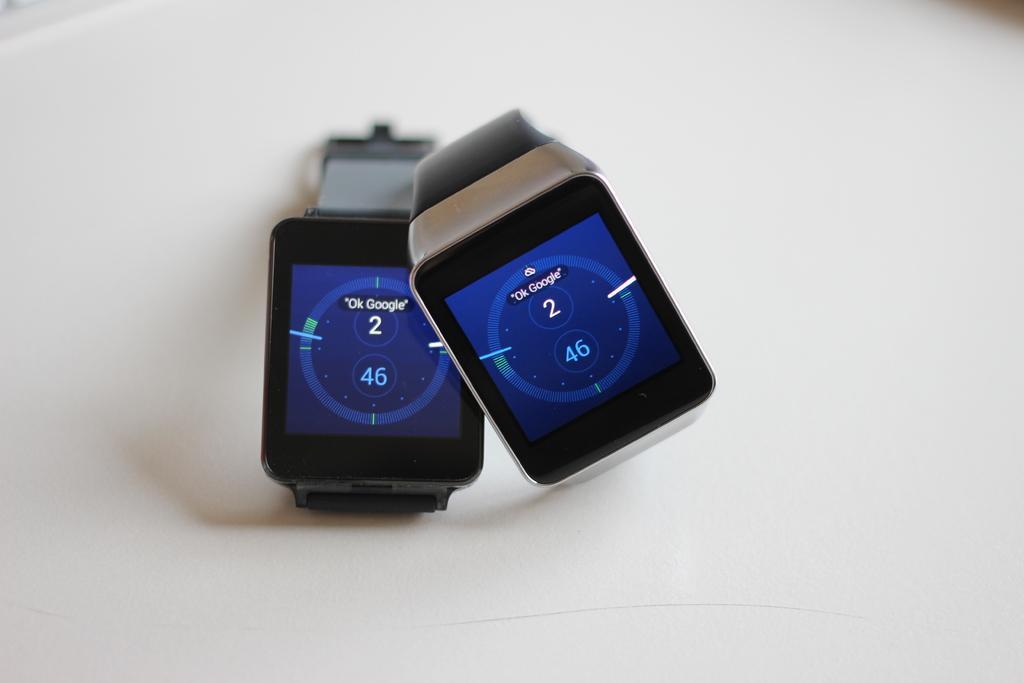Please provide a concise description of this image. In this image I can see two watches and the dial is in blue and black color, on the dial I can see few numbers and the background is in white color. 